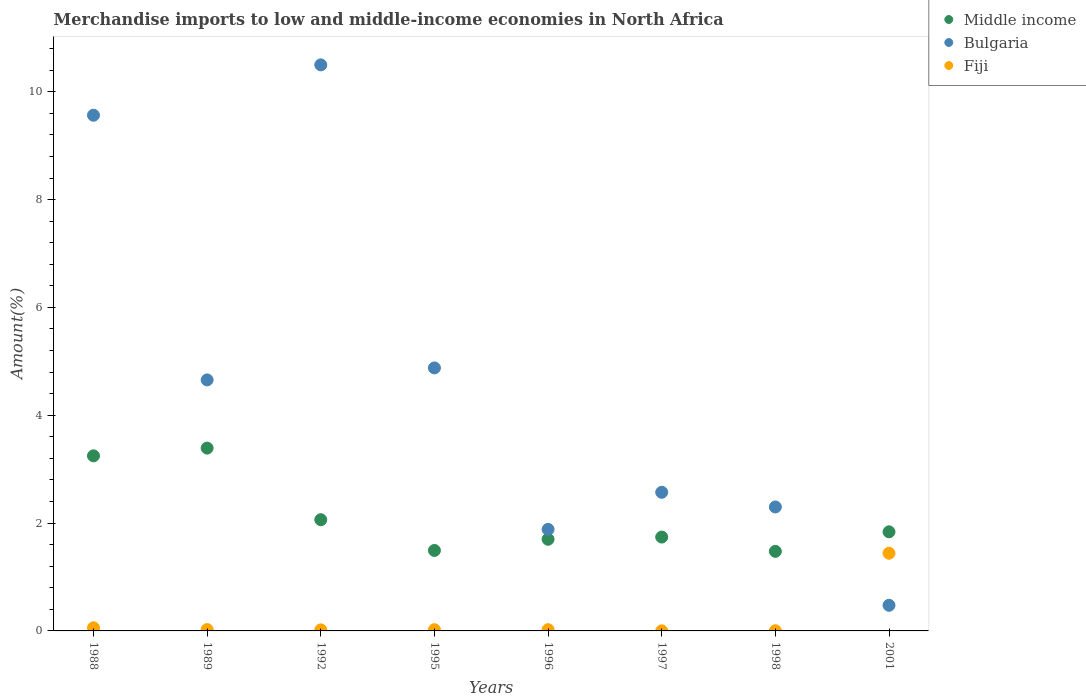What is the percentage of amount earned from merchandise imports in Bulgaria in 2001?
Give a very brief answer. 0.48. Across all years, what is the maximum percentage of amount earned from merchandise imports in Middle income?
Give a very brief answer. 3.39. Across all years, what is the minimum percentage of amount earned from merchandise imports in Middle income?
Your answer should be very brief. 1.48. In which year was the percentage of amount earned from merchandise imports in Fiji minimum?
Your answer should be compact. 1997. What is the total percentage of amount earned from merchandise imports in Bulgaria in the graph?
Ensure brevity in your answer.  36.83. What is the difference between the percentage of amount earned from merchandise imports in Fiji in 1992 and that in 2001?
Provide a succinct answer. -1.42. What is the difference between the percentage of amount earned from merchandise imports in Middle income in 1998 and the percentage of amount earned from merchandise imports in Fiji in 1996?
Provide a succinct answer. 1.45. What is the average percentage of amount earned from merchandise imports in Middle income per year?
Ensure brevity in your answer.  2.12. In the year 1988, what is the difference between the percentage of amount earned from merchandise imports in Fiji and percentage of amount earned from merchandise imports in Bulgaria?
Your response must be concise. -9.51. In how many years, is the percentage of amount earned from merchandise imports in Fiji greater than 4.4 %?
Ensure brevity in your answer.  0. What is the ratio of the percentage of amount earned from merchandise imports in Middle income in 1988 to that in 1996?
Your response must be concise. 1.91. Is the percentage of amount earned from merchandise imports in Bulgaria in 1995 less than that in 1996?
Provide a short and direct response. No. What is the difference between the highest and the second highest percentage of amount earned from merchandise imports in Bulgaria?
Your answer should be compact. 0.93. What is the difference between the highest and the lowest percentage of amount earned from merchandise imports in Fiji?
Keep it short and to the point. 1.44. Is the sum of the percentage of amount earned from merchandise imports in Bulgaria in 1989 and 2001 greater than the maximum percentage of amount earned from merchandise imports in Middle income across all years?
Offer a very short reply. Yes. Does the percentage of amount earned from merchandise imports in Fiji monotonically increase over the years?
Give a very brief answer. No. How many years are there in the graph?
Provide a short and direct response. 8. What is the difference between two consecutive major ticks on the Y-axis?
Offer a very short reply. 2. Are the values on the major ticks of Y-axis written in scientific E-notation?
Provide a short and direct response. No. Does the graph contain grids?
Your response must be concise. No. How are the legend labels stacked?
Offer a terse response. Vertical. What is the title of the graph?
Provide a short and direct response. Merchandise imports to low and middle-income economies in North Africa. What is the label or title of the X-axis?
Your answer should be very brief. Years. What is the label or title of the Y-axis?
Your answer should be compact. Amount(%). What is the Amount(%) of Middle income in 1988?
Your answer should be compact. 3.25. What is the Amount(%) in Bulgaria in 1988?
Make the answer very short. 9.56. What is the Amount(%) of Fiji in 1988?
Give a very brief answer. 0.06. What is the Amount(%) in Middle income in 1989?
Give a very brief answer. 3.39. What is the Amount(%) of Bulgaria in 1989?
Offer a very short reply. 4.66. What is the Amount(%) of Fiji in 1989?
Provide a short and direct response. 0.02. What is the Amount(%) in Middle income in 1992?
Give a very brief answer. 2.06. What is the Amount(%) in Bulgaria in 1992?
Provide a succinct answer. 10.5. What is the Amount(%) of Fiji in 1992?
Your answer should be very brief. 0.02. What is the Amount(%) of Middle income in 1995?
Your answer should be very brief. 1.49. What is the Amount(%) in Bulgaria in 1995?
Your answer should be compact. 4.88. What is the Amount(%) of Fiji in 1995?
Offer a terse response. 0.02. What is the Amount(%) of Middle income in 1996?
Offer a very short reply. 1.7. What is the Amount(%) in Bulgaria in 1996?
Offer a very short reply. 1.88. What is the Amount(%) of Fiji in 1996?
Your answer should be very brief. 0.02. What is the Amount(%) of Middle income in 1997?
Make the answer very short. 1.74. What is the Amount(%) in Bulgaria in 1997?
Keep it short and to the point. 2.57. What is the Amount(%) in Fiji in 1997?
Keep it short and to the point. 0. What is the Amount(%) of Middle income in 1998?
Ensure brevity in your answer.  1.48. What is the Amount(%) in Bulgaria in 1998?
Provide a succinct answer. 2.3. What is the Amount(%) of Fiji in 1998?
Give a very brief answer. 0. What is the Amount(%) in Middle income in 2001?
Give a very brief answer. 1.84. What is the Amount(%) of Bulgaria in 2001?
Offer a terse response. 0.48. What is the Amount(%) in Fiji in 2001?
Make the answer very short. 1.44. Across all years, what is the maximum Amount(%) in Middle income?
Offer a terse response. 3.39. Across all years, what is the maximum Amount(%) in Bulgaria?
Give a very brief answer. 10.5. Across all years, what is the maximum Amount(%) of Fiji?
Offer a terse response. 1.44. Across all years, what is the minimum Amount(%) of Middle income?
Offer a very short reply. 1.48. Across all years, what is the minimum Amount(%) of Bulgaria?
Offer a terse response. 0.48. Across all years, what is the minimum Amount(%) in Fiji?
Keep it short and to the point. 0. What is the total Amount(%) in Middle income in the graph?
Offer a terse response. 16.95. What is the total Amount(%) of Bulgaria in the graph?
Make the answer very short. 36.83. What is the total Amount(%) of Fiji in the graph?
Give a very brief answer. 1.59. What is the difference between the Amount(%) of Middle income in 1988 and that in 1989?
Offer a very short reply. -0.14. What is the difference between the Amount(%) in Bulgaria in 1988 and that in 1989?
Provide a succinct answer. 4.91. What is the difference between the Amount(%) in Fiji in 1988 and that in 1989?
Your answer should be compact. 0.03. What is the difference between the Amount(%) in Middle income in 1988 and that in 1992?
Offer a terse response. 1.18. What is the difference between the Amount(%) in Bulgaria in 1988 and that in 1992?
Give a very brief answer. -0.93. What is the difference between the Amount(%) of Fiji in 1988 and that in 1992?
Your answer should be compact. 0.04. What is the difference between the Amount(%) of Middle income in 1988 and that in 1995?
Give a very brief answer. 1.75. What is the difference between the Amount(%) of Bulgaria in 1988 and that in 1995?
Your response must be concise. 4.69. What is the difference between the Amount(%) in Fiji in 1988 and that in 1995?
Your answer should be compact. 0.04. What is the difference between the Amount(%) in Middle income in 1988 and that in 1996?
Provide a succinct answer. 1.55. What is the difference between the Amount(%) in Bulgaria in 1988 and that in 1996?
Your answer should be compact. 7.68. What is the difference between the Amount(%) of Fiji in 1988 and that in 1996?
Your answer should be very brief. 0.04. What is the difference between the Amount(%) of Middle income in 1988 and that in 1997?
Your answer should be compact. 1.51. What is the difference between the Amount(%) of Bulgaria in 1988 and that in 1997?
Your response must be concise. 6.99. What is the difference between the Amount(%) of Fiji in 1988 and that in 1997?
Give a very brief answer. 0.06. What is the difference between the Amount(%) in Middle income in 1988 and that in 1998?
Offer a very short reply. 1.77. What is the difference between the Amount(%) in Bulgaria in 1988 and that in 1998?
Offer a very short reply. 7.27. What is the difference between the Amount(%) in Fiji in 1988 and that in 1998?
Make the answer very short. 0.05. What is the difference between the Amount(%) in Middle income in 1988 and that in 2001?
Offer a terse response. 1.41. What is the difference between the Amount(%) of Bulgaria in 1988 and that in 2001?
Provide a short and direct response. 9.09. What is the difference between the Amount(%) of Fiji in 1988 and that in 2001?
Your answer should be very brief. -1.38. What is the difference between the Amount(%) of Middle income in 1989 and that in 1992?
Keep it short and to the point. 1.33. What is the difference between the Amount(%) of Bulgaria in 1989 and that in 1992?
Provide a succinct answer. -5.84. What is the difference between the Amount(%) in Fiji in 1989 and that in 1992?
Offer a very short reply. 0.01. What is the difference between the Amount(%) in Middle income in 1989 and that in 1995?
Offer a terse response. 1.9. What is the difference between the Amount(%) in Bulgaria in 1989 and that in 1995?
Ensure brevity in your answer.  -0.22. What is the difference between the Amount(%) of Fiji in 1989 and that in 1995?
Give a very brief answer. 0. What is the difference between the Amount(%) of Middle income in 1989 and that in 1996?
Your answer should be compact. 1.69. What is the difference between the Amount(%) of Bulgaria in 1989 and that in 1996?
Provide a short and direct response. 2.77. What is the difference between the Amount(%) in Fiji in 1989 and that in 1996?
Provide a short and direct response. 0. What is the difference between the Amount(%) of Middle income in 1989 and that in 1997?
Ensure brevity in your answer.  1.65. What is the difference between the Amount(%) of Bulgaria in 1989 and that in 1997?
Give a very brief answer. 2.08. What is the difference between the Amount(%) of Fiji in 1989 and that in 1997?
Make the answer very short. 0.02. What is the difference between the Amount(%) of Middle income in 1989 and that in 1998?
Give a very brief answer. 1.92. What is the difference between the Amount(%) in Bulgaria in 1989 and that in 1998?
Your response must be concise. 2.36. What is the difference between the Amount(%) of Fiji in 1989 and that in 1998?
Your response must be concise. 0.02. What is the difference between the Amount(%) of Middle income in 1989 and that in 2001?
Your answer should be compact. 1.55. What is the difference between the Amount(%) of Bulgaria in 1989 and that in 2001?
Give a very brief answer. 4.18. What is the difference between the Amount(%) in Fiji in 1989 and that in 2001?
Provide a succinct answer. -1.42. What is the difference between the Amount(%) in Middle income in 1992 and that in 1995?
Offer a terse response. 0.57. What is the difference between the Amount(%) of Bulgaria in 1992 and that in 1995?
Offer a very short reply. 5.62. What is the difference between the Amount(%) of Fiji in 1992 and that in 1995?
Keep it short and to the point. -0. What is the difference between the Amount(%) in Middle income in 1992 and that in 1996?
Provide a succinct answer. 0.36. What is the difference between the Amount(%) in Bulgaria in 1992 and that in 1996?
Provide a succinct answer. 8.62. What is the difference between the Amount(%) in Fiji in 1992 and that in 1996?
Your answer should be compact. -0. What is the difference between the Amount(%) in Middle income in 1992 and that in 1997?
Offer a very short reply. 0.32. What is the difference between the Amount(%) in Bulgaria in 1992 and that in 1997?
Make the answer very short. 7.93. What is the difference between the Amount(%) in Fiji in 1992 and that in 1997?
Provide a succinct answer. 0.02. What is the difference between the Amount(%) of Middle income in 1992 and that in 1998?
Make the answer very short. 0.59. What is the difference between the Amount(%) in Bulgaria in 1992 and that in 1998?
Offer a very short reply. 8.2. What is the difference between the Amount(%) of Fiji in 1992 and that in 1998?
Make the answer very short. 0.02. What is the difference between the Amount(%) in Middle income in 1992 and that in 2001?
Offer a terse response. 0.22. What is the difference between the Amount(%) of Bulgaria in 1992 and that in 2001?
Ensure brevity in your answer.  10.02. What is the difference between the Amount(%) in Fiji in 1992 and that in 2001?
Your response must be concise. -1.42. What is the difference between the Amount(%) of Middle income in 1995 and that in 1996?
Offer a terse response. -0.21. What is the difference between the Amount(%) in Bulgaria in 1995 and that in 1996?
Provide a succinct answer. 2.99. What is the difference between the Amount(%) in Fiji in 1995 and that in 1996?
Keep it short and to the point. -0. What is the difference between the Amount(%) of Middle income in 1995 and that in 1997?
Give a very brief answer. -0.25. What is the difference between the Amount(%) of Bulgaria in 1995 and that in 1997?
Make the answer very short. 2.31. What is the difference between the Amount(%) in Fiji in 1995 and that in 1997?
Give a very brief answer. 0.02. What is the difference between the Amount(%) of Middle income in 1995 and that in 1998?
Provide a succinct answer. 0.02. What is the difference between the Amount(%) in Bulgaria in 1995 and that in 1998?
Your response must be concise. 2.58. What is the difference between the Amount(%) in Fiji in 1995 and that in 1998?
Keep it short and to the point. 0.02. What is the difference between the Amount(%) in Middle income in 1995 and that in 2001?
Provide a short and direct response. -0.35. What is the difference between the Amount(%) of Bulgaria in 1995 and that in 2001?
Your answer should be compact. 4.4. What is the difference between the Amount(%) of Fiji in 1995 and that in 2001?
Offer a terse response. -1.42. What is the difference between the Amount(%) of Middle income in 1996 and that in 1997?
Keep it short and to the point. -0.04. What is the difference between the Amount(%) in Bulgaria in 1996 and that in 1997?
Your answer should be compact. -0.69. What is the difference between the Amount(%) in Fiji in 1996 and that in 1997?
Make the answer very short. 0.02. What is the difference between the Amount(%) in Middle income in 1996 and that in 1998?
Offer a terse response. 0.22. What is the difference between the Amount(%) in Bulgaria in 1996 and that in 1998?
Make the answer very short. -0.42. What is the difference between the Amount(%) of Fiji in 1996 and that in 1998?
Your answer should be very brief. 0.02. What is the difference between the Amount(%) of Middle income in 1996 and that in 2001?
Provide a short and direct response. -0.14. What is the difference between the Amount(%) in Bulgaria in 1996 and that in 2001?
Provide a short and direct response. 1.41. What is the difference between the Amount(%) in Fiji in 1996 and that in 2001?
Your answer should be compact. -1.42. What is the difference between the Amount(%) of Middle income in 1997 and that in 1998?
Your response must be concise. 0.27. What is the difference between the Amount(%) in Bulgaria in 1997 and that in 1998?
Your answer should be compact. 0.27. What is the difference between the Amount(%) in Fiji in 1997 and that in 1998?
Your response must be concise. -0. What is the difference between the Amount(%) of Middle income in 1997 and that in 2001?
Give a very brief answer. -0.1. What is the difference between the Amount(%) in Bulgaria in 1997 and that in 2001?
Your answer should be compact. 2.1. What is the difference between the Amount(%) in Fiji in 1997 and that in 2001?
Keep it short and to the point. -1.44. What is the difference between the Amount(%) of Middle income in 1998 and that in 2001?
Provide a short and direct response. -0.36. What is the difference between the Amount(%) of Bulgaria in 1998 and that in 2001?
Your answer should be very brief. 1.82. What is the difference between the Amount(%) of Fiji in 1998 and that in 2001?
Your answer should be very brief. -1.44. What is the difference between the Amount(%) in Middle income in 1988 and the Amount(%) in Bulgaria in 1989?
Your answer should be very brief. -1.41. What is the difference between the Amount(%) in Middle income in 1988 and the Amount(%) in Fiji in 1989?
Provide a succinct answer. 3.22. What is the difference between the Amount(%) in Bulgaria in 1988 and the Amount(%) in Fiji in 1989?
Keep it short and to the point. 9.54. What is the difference between the Amount(%) of Middle income in 1988 and the Amount(%) of Bulgaria in 1992?
Make the answer very short. -7.25. What is the difference between the Amount(%) of Middle income in 1988 and the Amount(%) of Fiji in 1992?
Keep it short and to the point. 3.23. What is the difference between the Amount(%) of Bulgaria in 1988 and the Amount(%) of Fiji in 1992?
Make the answer very short. 9.55. What is the difference between the Amount(%) of Middle income in 1988 and the Amount(%) of Bulgaria in 1995?
Your response must be concise. -1.63. What is the difference between the Amount(%) of Middle income in 1988 and the Amount(%) of Fiji in 1995?
Give a very brief answer. 3.22. What is the difference between the Amount(%) in Bulgaria in 1988 and the Amount(%) in Fiji in 1995?
Provide a succinct answer. 9.54. What is the difference between the Amount(%) of Middle income in 1988 and the Amount(%) of Bulgaria in 1996?
Your response must be concise. 1.36. What is the difference between the Amount(%) in Middle income in 1988 and the Amount(%) in Fiji in 1996?
Provide a short and direct response. 3.22. What is the difference between the Amount(%) in Bulgaria in 1988 and the Amount(%) in Fiji in 1996?
Your answer should be compact. 9.54. What is the difference between the Amount(%) in Middle income in 1988 and the Amount(%) in Bulgaria in 1997?
Offer a very short reply. 0.68. What is the difference between the Amount(%) of Middle income in 1988 and the Amount(%) of Fiji in 1997?
Offer a very short reply. 3.25. What is the difference between the Amount(%) of Bulgaria in 1988 and the Amount(%) of Fiji in 1997?
Provide a short and direct response. 9.56. What is the difference between the Amount(%) of Middle income in 1988 and the Amount(%) of Bulgaria in 1998?
Keep it short and to the point. 0.95. What is the difference between the Amount(%) of Middle income in 1988 and the Amount(%) of Fiji in 1998?
Ensure brevity in your answer.  3.24. What is the difference between the Amount(%) in Bulgaria in 1988 and the Amount(%) in Fiji in 1998?
Make the answer very short. 9.56. What is the difference between the Amount(%) of Middle income in 1988 and the Amount(%) of Bulgaria in 2001?
Keep it short and to the point. 2.77. What is the difference between the Amount(%) in Middle income in 1988 and the Amount(%) in Fiji in 2001?
Offer a terse response. 1.81. What is the difference between the Amount(%) in Bulgaria in 1988 and the Amount(%) in Fiji in 2001?
Your answer should be very brief. 8.12. What is the difference between the Amount(%) in Middle income in 1989 and the Amount(%) in Bulgaria in 1992?
Provide a short and direct response. -7.11. What is the difference between the Amount(%) of Middle income in 1989 and the Amount(%) of Fiji in 1992?
Provide a succinct answer. 3.37. What is the difference between the Amount(%) in Bulgaria in 1989 and the Amount(%) in Fiji in 1992?
Provide a succinct answer. 4.64. What is the difference between the Amount(%) of Middle income in 1989 and the Amount(%) of Bulgaria in 1995?
Give a very brief answer. -1.49. What is the difference between the Amount(%) in Middle income in 1989 and the Amount(%) in Fiji in 1995?
Your response must be concise. 3.37. What is the difference between the Amount(%) of Bulgaria in 1989 and the Amount(%) of Fiji in 1995?
Your response must be concise. 4.63. What is the difference between the Amount(%) of Middle income in 1989 and the Amount(%) of Bulgaria in 1996?
Provide a short and direct response. 1.51. What is the difference between the Amount(%) of Middle income in 1989 and the Amount(%) of Fiji in 1996?
Your response must be concise. 3.37. What is the difference between the Amount(%) in Bulgaria in 1989 and the Amount(%) in Fiji in 1996?
Offer a terse response. 4.63. What is the difference between the Amount(%) in Middle income in 1989 and the Amount(%) in Bulgaria in 1997?
Offer a very short reply. 0.82. What is the difference between the Amount(%) in Middle income in 1989 and the Amount(%) in Fiji in 1997?
Make the answer very short. 3.39. What is the difference between the Amount(%) of Bulgaria in 1989 and the Amount(%) of Fiji in 1997?
Keep it short and to the point. 4.65. What is the difference between the Amount(%) of Middle income in 1989 and the Amount(%) of Bulgaria in 1998?
Offer a very short reply. 1.09. What is the difference between the Amount(%) in Middle income in 1989 and the Amount(%) in Fiji in 1998?
Your answer should be compact. 3.39. What is the difference between the Amount(%) of Bulgaria in 1989 and the Amount(%) of Fiji in 1998?
Make the answer very short. 4.65. What is the difference between the Amount(%) in Middle income in 1989 and the Amount(%) in Bulgaria in 2001?
Your answer should be compact. 2.92. What is the difference between the Amount(%) of Middle income in 1989 and the Amount(%) of Fiji in 2001?
Your answer should be compact. 1.95. What is the difference between the Amount(%) in Bulgaria in 1989 and the Amount(%) in Fiji in 2001?
Ensure brevity in your answer.  3.21. What is the difference between the Amount(%) in Middle income in 1992 and the Amount(%) in Bulgaria in 1995?
Offer a terse response. -2.82. What is the difference between the Amount(%) of Middle income in 1992 and the Amount(%) of Fiji in 1995?
Offer a very short reply. 2.04. What is the difference between the Amount(%) in Bulgaria in 1992 and the Amount(%) in Fiji in 1995?
Your answer should be very brief. 10.48. What is the difference between the Amount(%) in Middle income in 1992 and the Amount(%) in Bulgaria in 1996?
Provide a succinct answer. 0.18. What is the difference between the Amount(%) in Middle income in 1992 and the Amount(%) in Fiji in 1996?
Your answer should be compact. 2.04. What is the difference between the Amount(%) of Bulgaria in 1992 and the Amount(%) of Fiji in 1996?
Ensure brevity in your answer.  10.48. What is the difference between the Amount(%) of Middle income in 1992 and the Amount(%) of Bulgaria in 1997?
Your answer should be compact. -0.51. What is the difference between the Amount(%) in Middle income in 1992 and the Amount(%) in Fiji in 1997?
Your response must be concise. 2.06. What is the difference between the Amount(%) of Bulgaria in 1992 and the Amount(%) of Fiji in 1997?
Provide a short and direct response. 10.5. What is the difference between the Amount(%) in Middle income in 1992 and the Amount(%) in Bulgaria in 1998?
Ensure brevity in your answer.  -0.24. What is the difference between the Amount(%) in Middle income in 1992 and the Amount(%) in Fiji in 1998?
Your response must be concise. 2.06. What is the difference between the Amount(%) in Bulgaria in 1992 and the Amount(%) in Fiji in 1998?
Provide a succinct answer. 10.5. What is the difference between the Amount(%) in Middle income in 1992 and the Amount(%) in Bulgaria in 2001?
Your response must be concise. 1.59. What is the difference between the Amount(%) in Middle income in 1992 and the Amount(%) in Fiji in 2001?
Provide a short and direct response. 0.62. What is the difference between the Amount(%) in Bulgaria in 1992 and the Amount(%) in Fiji in 2001?
Give a very brief answer. 9.06. What is the difference between the Amount(%) in Middle income in 1995 and the Amount(%) in Bulgaria in 1996?
Keep it short and to the point. -0.39. What is the difference between the Amount(%) in Middle income in 1995 and the Amount(%) in Fiji in 1996?
Your response must be concise. 1.47. What is the difference between the Amount(%) in Bulgaria in 1995 and the Amount(%) in Fiji in 1996?
Your response must be concise. 4.86. What is the difference between the Amount(%) of Middle income in 1995 and the Amount(%) of Bulgaria in 1997?
Ensure brevity in your answer.  -1.08. What is the difference between the Amount(%) of Middle income in 1995 and the Amount(%) of Fiji in 1997?
Ensure brevity in your answer.  1.49. What is the difference between the Amount(%) in Bulgaria in 1995 and the Amount(%) in Fiji in 1997?
Offer a terse response. 4.88. What is the difference between the Amount(%) in Middle income in 1995 and the Amount(%) in Bulgaria in 1998?
Ensure brevity in your answer.  -0.81. What is the difference between the Amount(%) in Middle income in 1995 and the Amount(%) in Fiji in 1998?
Offer a terse response. 1.49. What is the difference between the Amount(%) in Bulgaria in 1995 and the Amount(%) in Fiji in 1998?
Offer a very short reply. 4.87. What is the difference between the Amount(%) of Middle income in 1995 and the Amount(%) of Bulgaria in 2001?
Offer a terse response. 1.02. What is the difference between the Amount(%) in Middle income in 1995 and the Amount(%) in Fiji in 2001?
Make the answer very short. 0.05. What is the difference between the Amount(%) of Bulgaria in 1995 and the Amount(%) of Fiji in 2001?
Your answer should be very brief. 3.44. What is the difference between the Amount(%) in Middle income in 1996 and the Amount(%) in Bulgaria in 1997?
Provide a succinct answer. -0.87. What is the difference between the Amount(%) of Middle income in 1996 and the Amount(%) of Fiji in 1997?
Give a very brief answer. 1.7. What is the difference between the Amount(%) of Bulgaria in 1996 and the Amount(%) of Fiji in 1997?
Offer a terse response. 1.88. What is the difference between the Amount(%) in Middle income in 1996 and the Amount(%) in Bulgaria in 1998?
Your answer should be very brief. -0.6. What is the difference between the Amount(%) of Middle income in 1996 and the Amount(%) of Fiji in 1998?
Provide a succinct answer. 1.7. What is the difference between the Amount(%) of Bulgaria in 1996 and the Amount(%) of Fiji in 1998?
Provide a succinct answer. 1.88. What is the difference between the Amount(%) in Middle income in 1996 and the Amount(%) in Bulgaria in 2001?
Ensure brevity in your answer.  1.22. What is the difference between the Amount(%) in Middle income in 1996 and the Amount(%) in Fiji in 2001?
Provide a short and direct response. 0.26. What is the difference between the Amount(%) in Bulgaria in 1996 and the Amount(%) in Fiji in 2001?
Provide a short and direct response. 0.44. What is the difference between the Amount(%) in Middle income in 1997 and the Amount(%) in Bulgaria in 1998?
Ensure brevity in your answer.  -0.56. What is the difference between the Amount(%) in Middle income in 1997 and the Amount(%) in Fiji in 1998?
Offer a terse response. 1.74. What is the difference between the Amount(%) of Bulgaria in 1997 and the Amount(%) of Fiji in 1998?
Your response must be concise. 2.57. What is the difference between the Amount(%) in Middle income in 1997 and the Amount(%) in Bulgaria in 2001?
Your answer should be very brief. 1.27. What is the difference between the Amount(%) in Middle income in 1997 and the Amount(%) in Fiji in 2001?
Provide a succinct answer. 0.3. What is the difference between the Amount(%) in Bulgaria in 1997 and the Amount(%) in Fiji in 2001?
Provide a succinct answer. 1.13. What is the difference between the Amount(%) of Middle income in 1998 and the Amount(%) of Bulgaria in 2001?
Ensure brevity in your answer.  1. What is the difference between the Amount(%) of Middle income in 1998 and the Amount(%) of Fiji in 2001?
Keep it short and to the point. 0.03. What is the difference between the Amount(%) in Bulgaria in 1998 and the Amount(%) in Fiji in 2001?
Your answer should be very brief. 0.86. What is the average Amount(%) in Middle income per year?
Provide a succinct answer. 2.12. What is the average Amount(%) of Bulgaria per year?
Provide a short and direct response. 4.6. What is the average Amount(%) of Fiji per year?
Your response must be concise. 0.2. In the year 1988, what is the difference between the Amount(%) of Middle income and Amount(%) of Bulgaria?
Your answer should be very brief. -6.32. In the year 1988, what is the difference between the Amount(%) in Middle income and Amount(%) in Fiji?
Make the answer very short. 3.19. In the year 1988, what is the difference between the Amount(%) in Bulgaria and Amount(%) in Fiji?
Offer a very short reply. 9.51. In the year 1989, what is the difference between the Amount(%) in Middle income and Amount(%) in Bulgaria?
Make the answer very short. -1.26. In the year 1989, what is the difference between the Amount(%) of Middle income and Amount(%) of Fiji?
Provide a short and direct response. 3.37. In the year 1989, what is the difference between the Amount(%) of Bulgaria and Amount(%) of Fiji?
Provide a succinct answer. 4.63. In the year 1992, what is the difference between the Amount(%) in Middle income and Amount(%) in Bulgaria?
Make the answer very short. -8.44. In the year 1992, what is the difference between the Amount(%) in Middle income and Amount(%) in Fiji?
Your response must be concise. 2.04. In the year 1992, what is the difference between the Amount(%) in Bulgaria and Amount(%) in Fiji?
Offer a very short reply. 10.48. In the year 1995, what is the difference between the Amount(%) in Middle income and Amount(%) in Bulgaria?
Your answer should be compact. -3.39. In the year 1995, what is the difference between the Amount(%) in Middle income and Amount(%) in Fiji?
Provide a succinct answer. 1.47. In the year 1995, what is the difference between the Amount(%) of Bulgaria and Amount(%) of Fiji?
Give a very brief answer. 4.86. In the year 1996, what is the difference between the Amount(%) of Middle income and Amount(%) of Bulgaria?
Provide a succinct answer. -0.18. In the year 1996, what is the difference between the Amount(%) in Middle income and Amount(%) in Fiji?
Your response must be concise. 1.68. In the year 1996, what is the difference between the Amount(%) in Bulgaria and Amount(%) in Fiji?
Your answer should be very brief. 1.86. In the year 1997, what is the difference between the Amount(%) in Middle income and Amount(%) in Bulgaria?
Your answer should be compact. -0.83. In the year 1997, what is the difference between the Amount(%) of Middle income and Amount(%) of Fiji?
Keep it short and to the point. 1.74. In the year 1997, what is the difference between the Amount(%) of Bulgaria and Amount(%) of Fiji?
Offer a terse response. 2.57. In the year 1998, what is the difference between the Amount(%) of Middle income and Amount(%) of Bulgaria?
Offer a very short reply. -0.82. In the year 1998, what is the difference between the Amount(%) of Middle income and Amount(%) of Fiji?
Offer a terse response. 1.47. In the year 1998, what is the difference between the Amount(%) in Bulgaria and Amount(%) in Fiji?
Make the answer very short. 2.3. In the year 2001, what is the difference between the Amount(%) in Middle income and Amount(%) in Bulgaria?
Give a very brief answer. 1.36. In the year 2001, what is the difference between the Amount(%) of Middle income and Amount(%) of Fiji?
Your response must be concise. 0.4. In the year 2001, what is the difference between the Amount(%) of Bulgaria and Amount(%) of Fiji?
Provide a succinct answer. -0.97. What is the ratio of the Amount(%) of Middle income in 1988 to that in 1989?
Ensure brevity in your answer.  0.96. What is the ratio of the Amount(%) in Bulgaria in 1988 to that in 1989?
Offer a terse response. 2.05. What is the ratio of the Amount(%) in Fiji in 1988 to that in 1989?
Offer a very short reply. 2.37. What is the ratio of the Amount(%) of Middle income in 1988 to that in 1992?
Provide a short and direct response. 1.57. What is the ratio of the Amount(%) of Bulgaria in 1988 to that in 1992?
Keep it short and to the point. 0.91. What is the ratio of the Amount(%) of Fiji in 1988 to that in 1992?
Ensure brevity in your answer.  3.03. What is the ratio of the Amount(%) in Middle income in 1988 to that in 1995?
Provide a succinct answer. 2.18. What is the ratio of the Amount(%) of Bulgaria in 1988 to that in 1995?
Offer a very short reply. 1.96. What is the ratio of the Amount(%) of Fiji in 1988 to that in 1995?
Offer a terse response. 2.57. What is the ratio of the Amount(%) in Middle income in 1988 to that in 1996?
Your answer should be very brief. 1.91. What is the ratio of the Amount(%) in Bulgaria in 1988 to that in 1996?
Offer a very short reply. 5.08. What is the ratio of the Amount(%) in Fiji in 1988 to that in 1996?
Your response must be concise. 2.52. What is the ratio of the Amount(%) of Middle income in 1988 to that in 1997?
Your response must be concise. 1.87. What is the ratio of the Amount(%) in Bulgaria in 1988 to that in 1997?
Provide a short and direct response. 3.72. What is the ratio of the Amount(%) in Fiji in 1988 to that in 1997?
Provide a short and direct response. 36.46. What is the ratio of the Amount(%) of Middle income in 1988 to that in 1998?
Your response must be concise. 2.2. What is the ratio of the Amount(%) in Bulgaria in 1988 to that in 1998?
Your response must be concise. 4.16. What is the ratio of the Amount(%) in Fiji in 1988 to that in 1998?
Your answer should be very brief. 17.43. What is the ratio of the Amount(%) in Middle income in 1988 to that in 2001?
Offer a very short reply. 1.77. What is the ratio of the Amount(%) of Bulgaria in 1988 to that in 2001?
Provide a succinct answer. 20.12. What is the ratio of the Amount(%) of Fiji in 1988 to that in 2001?
Offer a very short reply. 0.04. What is the ratio of the Amount(%) in Middle income in 1989 to that in 1992?
Your answer should be compact. 1.64. What is the ratio of the Amount(%) of Bulgaria in 1989 to that in 1992?
Your answer should be very brief. 0.44. What is the ratio of the Amount(%) of Fiji in 1989 to that in 1992?
Provide a succinct answer. 1.28. What is the ratio of the Amount(%) of Middle income in 1989 to that in 1995?
Keep it short and to the point. 2.27. What is the ratio of the Amount(%) of Bulgaria in 1989 to that in 1995?
Make the answer very short. 0.95. What is the ratio of the Amount(%) of Fiji in 1989 to that in 1995?
Provide a succinct answer. 1.08. What is the ratio of the Amount(%) of Middle income in 1989 to that in 1996?
Give a very brief answer. 1.99. What is the ratio of the Amount(%) of Bulgaria in 1989 to that in 1996?
Your response must be concise. 2.47. What is the ratio of the Amount(%) of Fiji in 1989 to that in 1996?
Provide a short and direct response. 1.06. What is the ratio of the Amount(%) in Middle income in 1989 to that in 1997?
Give a very brief answer. 1.95. What is the ratio of the Amount(%) of Bulgaria in 1989 to that in 1997?
Ensure brevity in your answer.  1.81. What is the ratio of the Amount(%) of Fiji in 1989 to that in 1997?
Offer a very short reply. 15.39. What is the ratio of the Amount(%) of Middle income in 1989 to that in 1998?
Your answer should be very brief. 2.3. What is the ratio of the Amount(%) in Bulgaria in 1989 to that in 1998?
Your answer should be compact. 2.03. What is the ratio of the Amount(%) in Fiji in 1989 to that in 1998?
Keep it short and to the point. 7.36. What is the ratio of the Amount(%) of Middle income in 1989 to that in 2001?
Your response must be concise. 1.84. What is the ratio of the Amount(%) of Bulgaria in 1989 to that in 2001?
Provide a short and direct response. 9.79. What is the ratio of the Amount(%) in Fiji in 1989 to that in 2001?
Ensure brevity in your answer.  0.02. What is the ratio of the Amount(%) of Middle income in 1992 to that in 1995?
Your answer should be very brief. 1.38. What is the ratio of the Amount(%) in Bulgaria in 1992 to that in 1995?
Offer a very short reply. 2.15. What is the ratio of the Amount(%) of Fiji in 1992 to that in 1995?
Offer a very short reply. 0.85. What is the ratio of the Amount(%) in Middle income in 1992 to that in 1996?
Your response must be concise. 1.21. What is the ratio of the Amount(%) in Bulgaria in 1992 to that in 1996?
Offer a terse response. 5.57. What is the ratio of the Amount(%) of Fiji in 1992 to that in 1996?
Your answer should be very brief. 0.83. What is the ratio of the Amount(%) of Middle income in 1992 to that in 1997?
Ensure brevity in your answer.  1.18. What is the ratio of the Amount(%) of Bulgaria in 1992 to that in 1997?
Ensure brevity in your answer.  4.08. What is the ratio of the Amount(%) of Fiji in 1992 to that in 1997?
Give a very brief answer. 12.03. What is the ratio of the Amount(%) in Middle income in 1992 to that in 1998?
Ensure brevity in your answer.  1.4. What is the ratio of the Amount(%) of Bulgaria in 1992 to that in 1998?
Offer a terse response. 4.57. What is the ratio of the Amount(%) of Fiji in 1992 to that in 1998?
Provide a short and direct response. 5.75. What is the ratio of the Amount(%) of Middle income in 1992 to that in 2001?
Your answer should be very brief. 1.12. What is the ratio of the Amount(%) in Bulgaria in 1992 to that in 2001?
Your answer should be very brief. 22.08. What is the ratio of the Amount(%) in Fiji in 1992 to that in 2001?
Your response must be concise. 0.01. What is the ratio of the Amount(%) in Middle income in 1995 to that in 1996?
Ensure brevity in your answer.  0.88. What is the ratio of the Amount(%) of Bulgaria in 1995 to that in 1996?
Offer a very short reply. 2.59. What is the ratio of the Amount(%) in Fiji in 1995 to that in 1996?
Offer a very short reply. 0.98. What is the ratio of the Amount(%) in Middle income in 1995 to that in 1997?
Your answer should be very brief. 0.86. What is the ratio of the Amount(%) of Bulgaria in 1995 to that in 1997?
Your answer should be very brief. 1.9. What is the ratio of the Amount(%) of Fiji in 1995 to that in 1997?
Give a very brief answer. 14.21. What is the ratio of the Amount(%) of Middle income in 1995 to that in 1998?
Your answer should be compact. 1.01. What is the ratio of the Amount(%) in Bulgaria in 1995 to that in 1998?
Ensure brevity in your answer.  2.12. What is the ratio of the Amount(%) of Fiji in 1995 to that in 1998?
Ensure brevity in your answer.  6.79. What is the ratio of the Amount(%) of Middle income in 1995 to that in 2001?
Offer a very short reply. 0.81. What is the ratio of the Amount(%) in Bulgaria in 1995 to that in 2001?
Provide a succinct answer. 10.26. What is the ratio of the Amount(%) in Fiji in 1995 to that in 2001?
Offer a very short reply. 0.02. What is the ratio of the Amount(%) in Middle income in 1996 to that in 1997?
Provide a short and direct response. 0.98. What is the ratio of the Amount(%) in Bulgaria in 1996 to that in 1997?
Offer a very short reply. 0.73. What is the ratio of the Amount(%) in Fiji in 1996 to that in 1997?
Offer a very short reply. 14.49. What is the ratio of the Amount(%) of Middle income in 1996 to that in 1998?
Keep it short and to the point. 1.15. What is the ratio of the Amount(%) in Bulgaria in 1996 to that in 1998?
Your response must be concise. 0.82. What is the ratio of the Amount(%) in Fiji in 1996 to that in 1998?
Your response must be concise. 6.93. What is the ratio of the Amount(%) in Middle income in 1996 to that in 2001?
Your answer should be very brief. 0.92. What is the ratio of the Amount(%) in Bulgaria in 1996 to that in 2001?
Your answer should be compact. 3.96. What is the ratio of the Amount(%) in Fiji in 1996 to that in 2001?
Keep it short and to the point. 0.02. What is the ratio of the Amount(%) of Middle income in 1997 to that in 1998?
Ensure brevity in your answer.  1.18. What is the ratio of the Amount(%) in Bulgaria in 1997 to that in 1998?
Make the answer very short. 1.12. What is the ratio of the Amount(%) of Fiji in 1997 to that in 1998?
Your response must be concise. 0.48. What is the ratio of the Amount(%) in Middle income in 1997 to that in 2001?
Give a very brief answer. 0.95. What is the ratio of the Amount(%) in Bulgaria in 1997 to that in 2001?
Provide a succinct answer. 5.41. What is the ratio of the Amount(%) in Fiji in 1997 to that in 2001?
Your response must be concise. 0. What is the ratio of the Amount(%) in Middle income in 1998 to that in 2001?
Make the answer very short. 0.8. What is the ratio of the Amount(%) of Bulgaria in 1998 to that in 2001?
Offer a terse response. 4.84. What is the ratio of the Amount(%) of Fiji in 1998 to that in 2001?
Offer a very short reply. 0. What is the difference between the highest and the second highest Amount(%) of Middle income?
Offer a terse response. 0.14. What is the difference between the highest and the second highest Amount(%) in Bulgaria?
Provide a succinct answer. 0.93. What is the difference between the highest and the second highest Amount(%) of Fiji?
Provide a succinct answer. 1.38. What is the difference between the highest and the lowest Amount(%) of Middle income?
Give a very brief answer. 1.92. What is the difference between the highest and the lowest Amount(%) of Bulgaria?
Give a very brief answer. 10.02. What is the difference between the highest and the lowest Amount(%) in Fiji?
Your answer should be compact. 1.44. 